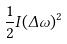<formula> <loc_0><loc_0><loc_500><loc_500>\frac { 1 } { 2 } I ( \Delta \omega ) ^ { 2 }</formula> 